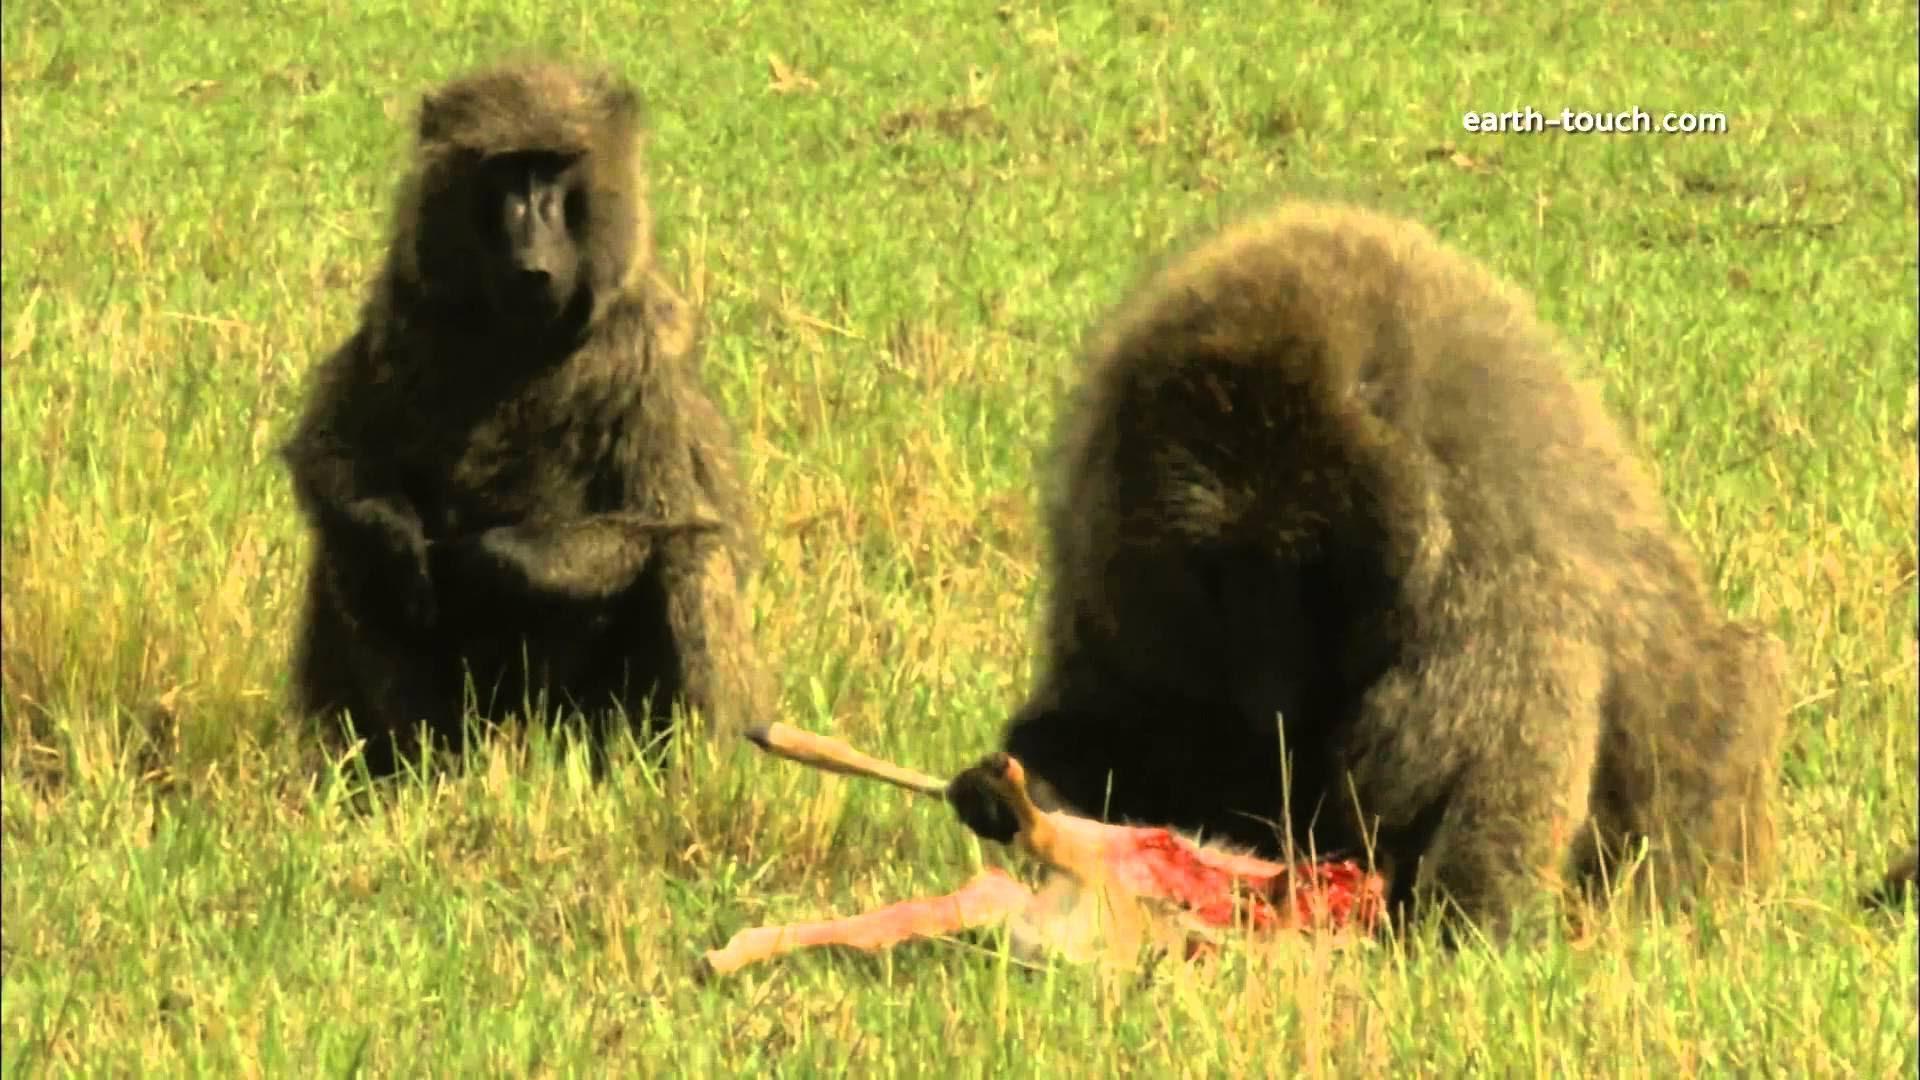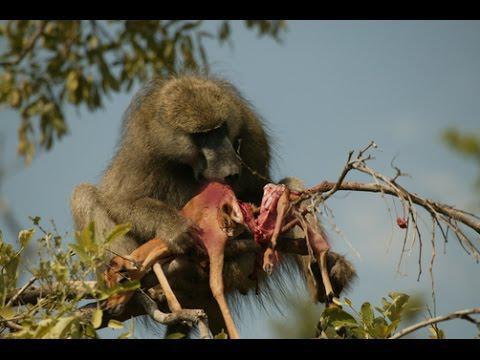The first image is the image on the left, the second image is the image on the right. Given the left and right images, does the statement "The image on the left contains no less than two baboons sitting in a grassy field." hold true? Answer yes or no. Yes. The first image is the image on the left, the second image is the image on the right. Examine the images to the left and right. Is the description "There are exactly two baboons in at least one of the images." accurate? Answer yes or no. Yes. 